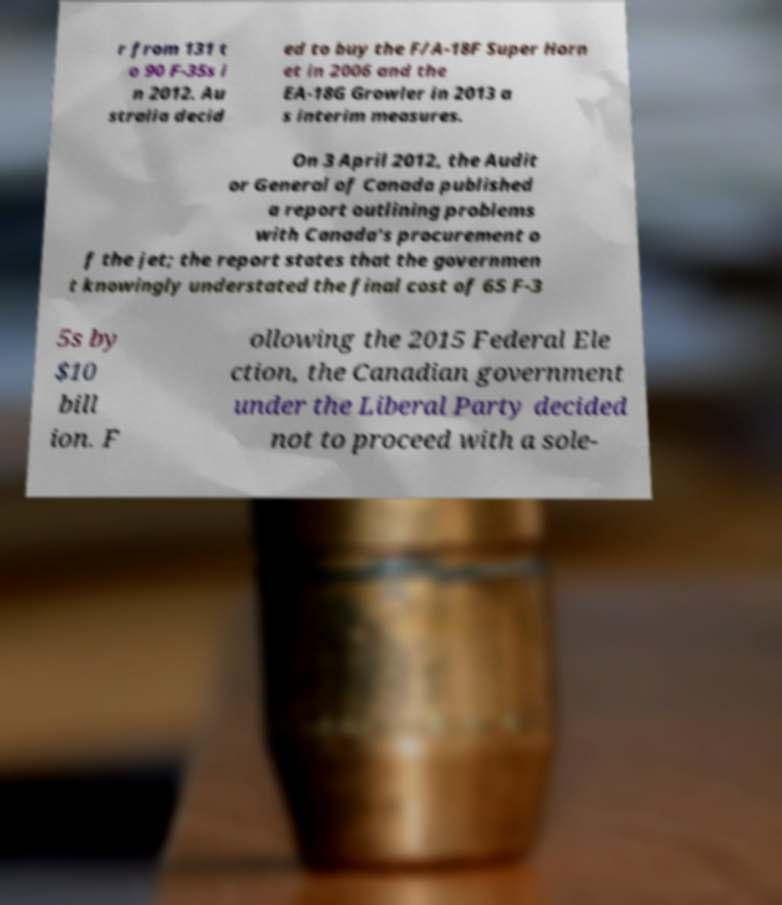Please read and relay the text visible in this image. What does it say? r from 131 t o 90 F-35s i n 2012. Au stralia decid ed to buy the F/A-18F Super Horn et in 2006 and the EA-18G Growler in 2013 a s interim measures. On 3 April 2012, the Audit or General of Canada published a report outlining problems with Canada's procurement o f the jet; the report states that the governmen t knowingly understated the final cost of 65 F-3 5s by $10 bill ion. F ollowing the 2015 Federal Ele ction, the Canadian government under the Liberal Party decided not to proceed with a sole- 